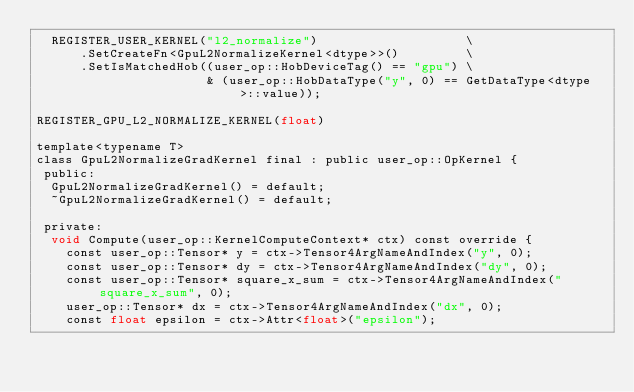<code> <loc_0><loc_0><loc_500><loc_500><_Cuda_>  REGISTER_USER_KERNEL("l2_normalize")                    \
      .SetCreateFn<GpuL2NormalizeKernel<dtype>>()         \
      .SetIsMatchedHob((user_op::HobDeviceTag() == "gpu") \
                       & (user_op::HobDataType("y", 0) == GetDataType<dtype>::value));

REGISTER_GPU_L2_NORMALIZE_KERNEL(float)

template<typename T>
class GpuL2NormalizeGradKernel final : public user_op::OpKernel {
 public:
  GpuL2NormalizeGradKernel() = default;
  ~GpuL2NormalizeGradKernel() = default;

 private:
  void Compute(user_op::KernelComputeContext* ctx) const override {
    const user_op::Tensor* y = ctx->Tensor4ArgNameAndIndex("y", 0);
    const user_op::Tensor* dy = ctx->Tensor4ArgNameAndIndex("dy", 0);
    const user_op::Tensor* square_x_sum = ctx->Tensor4ArgNameAndIndex("square_x_sum", 0);
    user_op::Tensor* dx = ctx->Tensor4ArgNameAndIndex("dx", 0);
    const float epsilon = ctx->Attr<float>("epsilon");</code> 